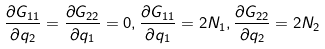<formula> <loc_0><loc_0><loc_500><loc_500>\frac { \partial G _ { 1 1 } } { \partial q _ { 2 } } = \frac { \partial G _ { 2 2 } } { \partial q _ { 1 } } = 0 , \frac { \partial G _ { 1 1 } } { \partial q _ { 1 } } = 2 N _ { 1 } , \frac { \partial G _ { 2 2 } } { \partial q _ { 2 } } = 2 N _ { 2 }</formula> 